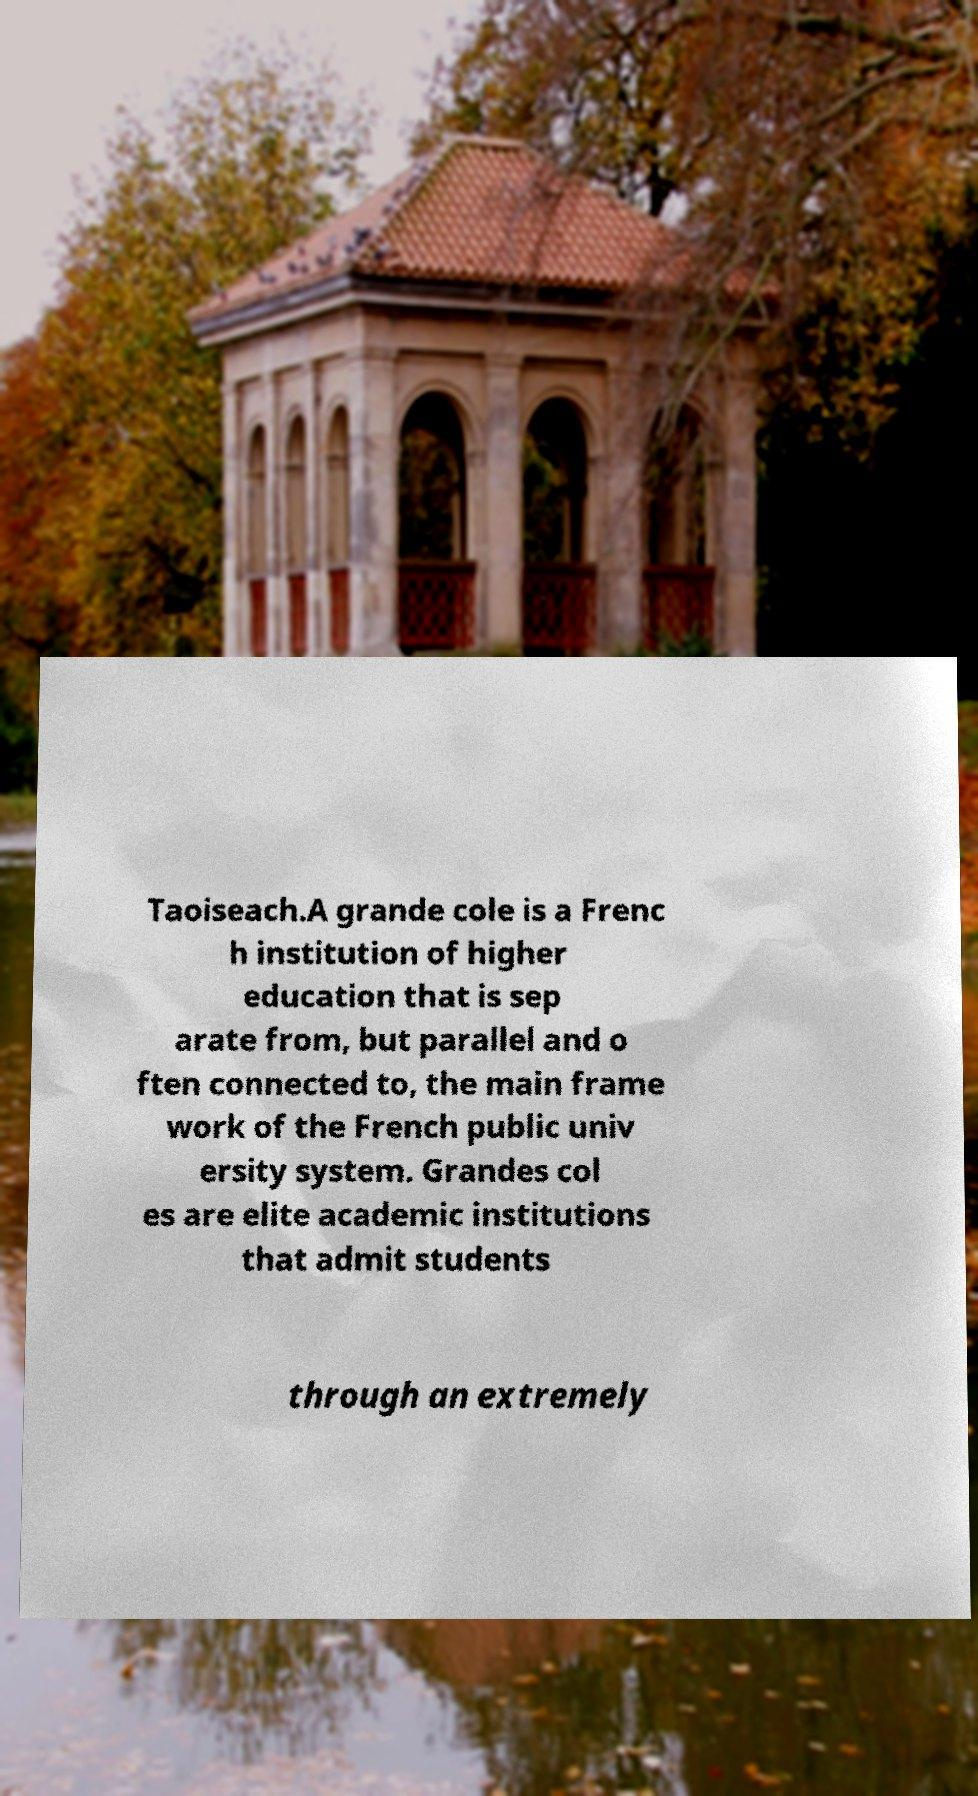Could you extract and type out the text from this image? Taoiseach.A grande cole is a Frenc h institution of higher education that is sep arate from, but parallel and o ften connected to, the main frame work of the French public univ ersity system. Grandes col es are elite academic institutions that admit students through an extremely 